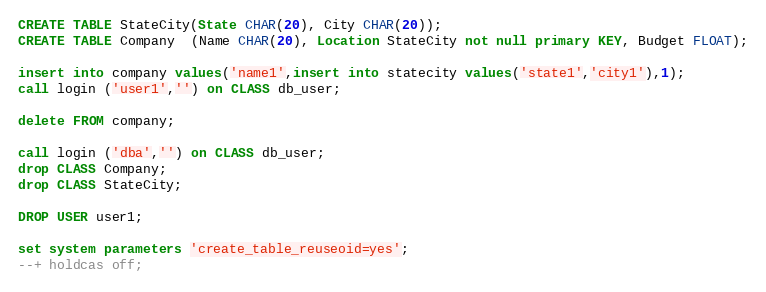<code> <loc_0><loc_0><loc_500><loc_500><_SQL_>CREATE TABLE StateCity(State CHAR(20), City CHAR(20));
CREATE TABLE Company  (Name CHAR(20), Location StateCity not null primary KEY, Budget FLOAT);

insert into company values('name1',insert into statecity values('state1','city1'),1);
call login ('user1','') on CLASS db_user;

delete FROM company;

call login ('dba','') on CLASS db_user;
drop CLASS Company;
drop CLASS StateCity;

DROP USER user1;

set system parameters 'create_table_reuseoid=yes';
--+ holdcas off;
</code> 